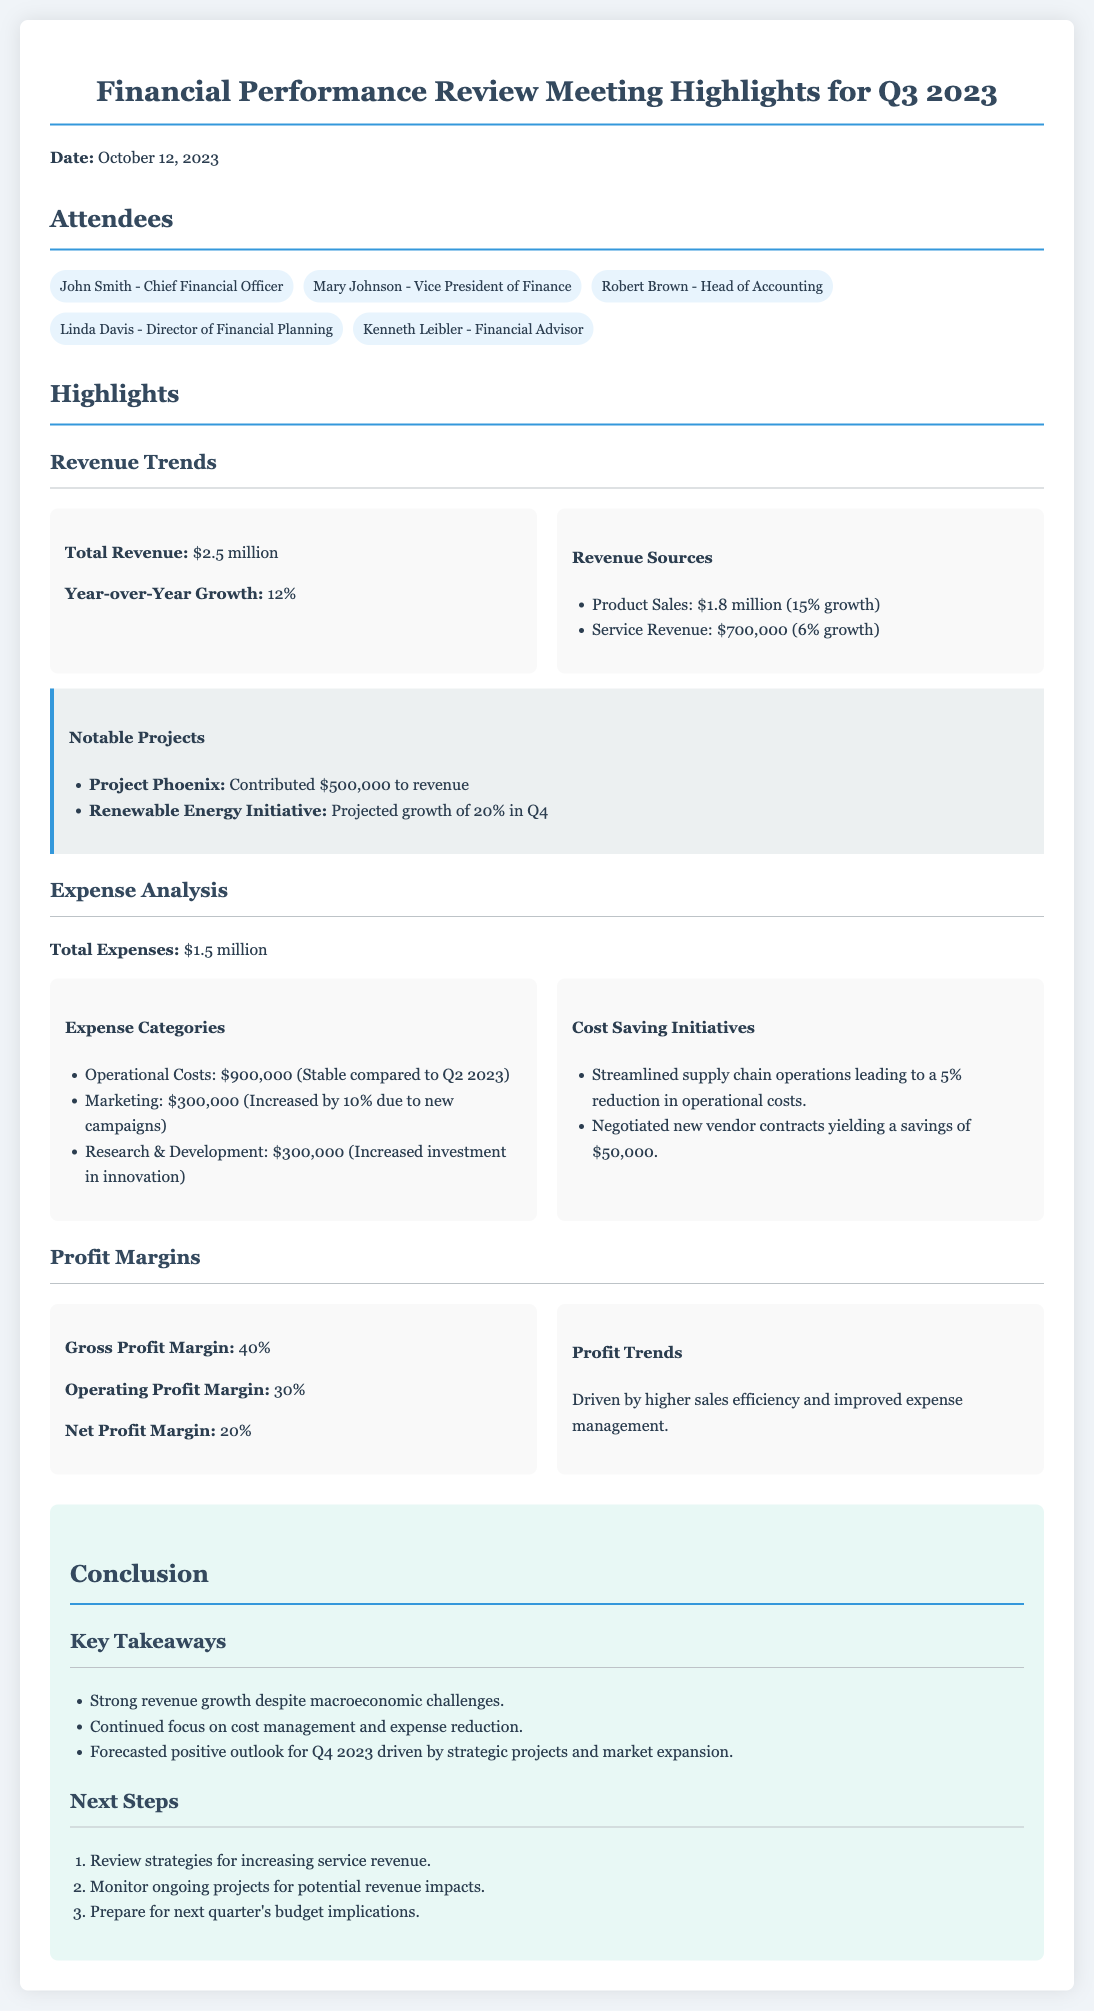what is the total revenue? The total revenue listed in the document is $2.5 million.
Answer: $2.5 million what was the year-over-year growth percentage? The year-over-year growth percentage for Q3 2023 is provided in the document as 12%.
Answer: 12% what is the total expense amount? The total expenses for Q3 2023 are explicitly mentioned as $1.5 million.
Answer: $1.5 million what are the operational costs? The document states that operational costs are $900,000.
Answer: $900,000 what is the net profit margin? The net profit margin for Q3 2023 is presented as 20%.
Answer: 20% which notable project contributed $500,000 to revenue? The document identifies Project Phoenix as having contributed $500,000 to revenue.
Answer: Project Phoenix what was the increase percentage in marketing expenses? The increase percentage in marketing expenses is noted as 10%.
Answer: 10% who attended the meeting as a financial advisor? Kenneth Leibler is mentioned as the financial advisor who attended the meeting.
Answer: Kenneth Leibler what are the key takeaways highlighted in the conclusion? The conclusion lists strong revenue growth, focus on cost management, and a positive outlook for Q4 2023.
Answer: Strong revenue growth, focus on cost management, positive outlook for Q4 2023 